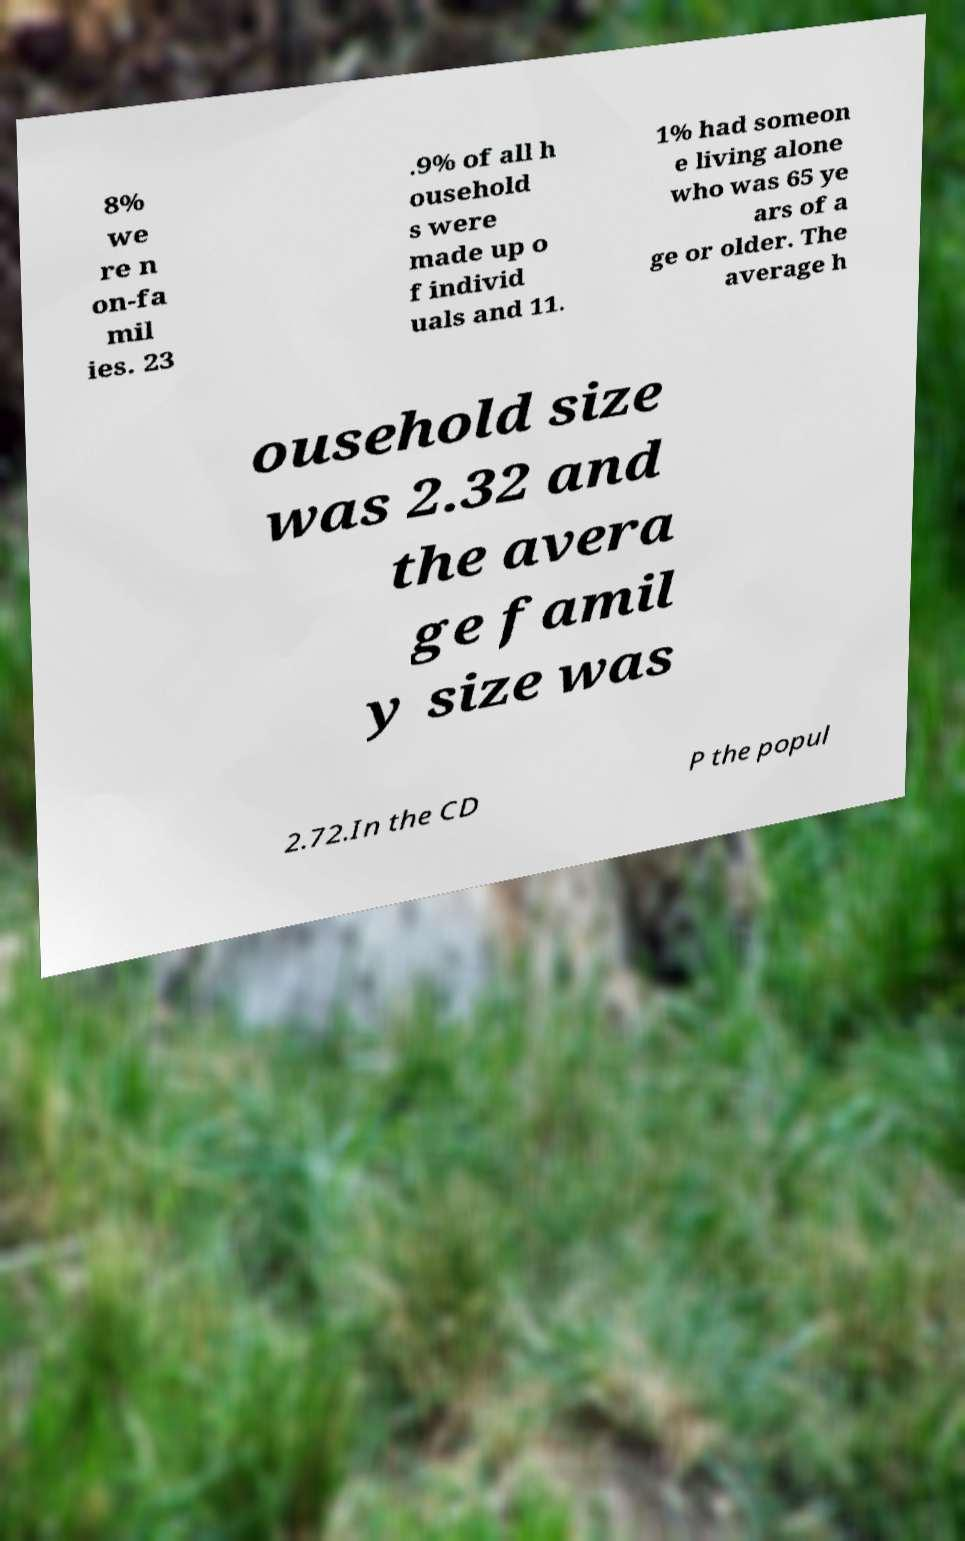Can you accurately transcribe the text from the provided image for me? 8% we re n on-fa mil ies. 23 .9% of all h ousehold s were made up o f individ uals and 11. 1% had someon e living alone who was 65 ye ars of a ge or older. The average h ousehold size was 2.32 and the avera ge famil y size was 2.72.In the CD P the popul 